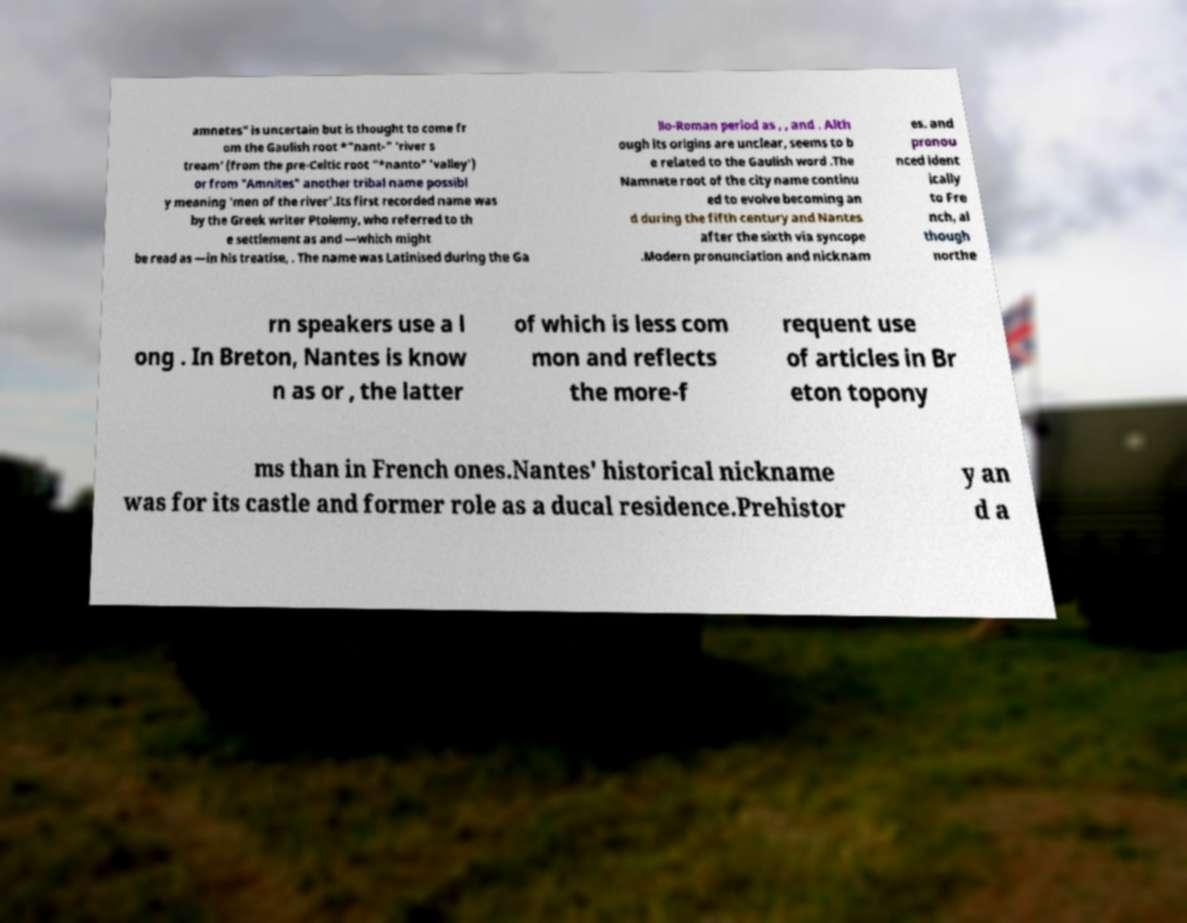Please read and relay the text visible in this image. What does it say? amnetes" is uncertain but is thought to come fr om the Gaulish root *"nant-" 'river s tream' (from the pre-Celtic root "*nanto" 'valley') or from "Amnites" another tribal name possibl y meaning 'men of the river'.Its first recorded name was by the Greek writer Ptolemy, who referred to th e settlement as and —which might be read as —in his treatise, . The name was Latinised during the Ga llo-Roman period as , , and . Alth ough its origins are unclear, seems to b e related to the Gaulish word .The Namnete root of the city name continu ed to evolve becoming an d during the fifth century and Nantes after the sixth via syncope .Modern pronunciation and nicknam es. and pronou nced ident ically to Fre nch, al though northe rn speakers use a l ong . In Breton, Nantes is know n as or , the latter of which is less com mon and reflects the more-f requent use of articles in Br eton topony ms than in French ones.Nantes' historical nickname was for its castle and former role as a ducal residence.Prehistor y an d a 